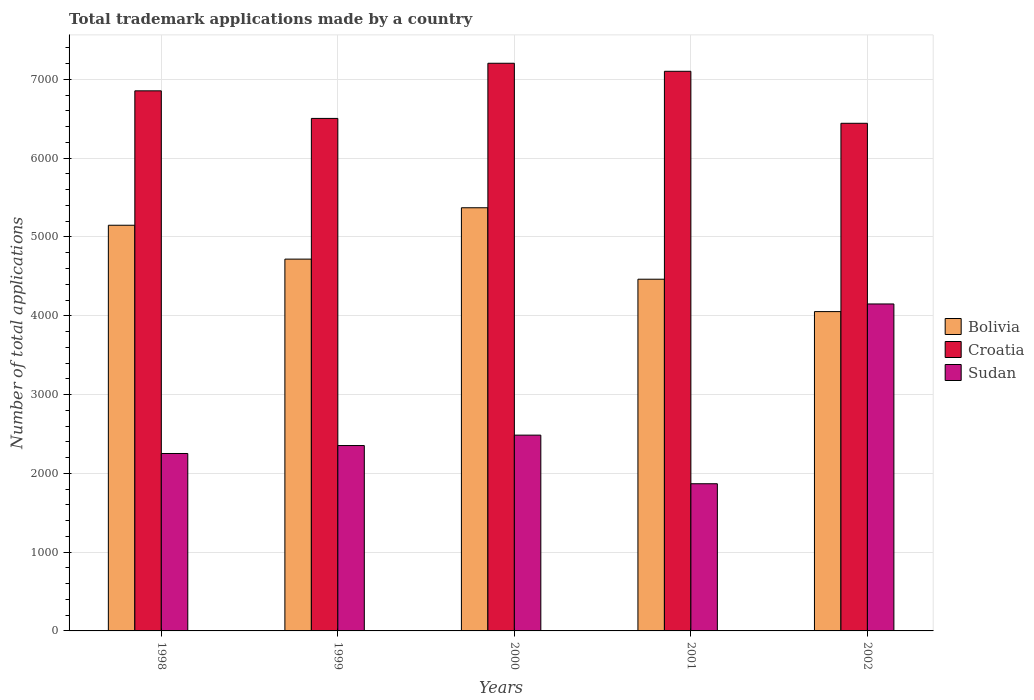How many different coloured bars are there?
Provide a short and direct response. 3. How many groups of bars are there?
Make the answer very short. 5. Are the number of bars on each tick of the X-axis equal?
Offer a terse response. Yes. How many bars are there on the 1st tick from the left?
Provide a short and direct response. 3. What is the number of applications made by in Sudan in 1999?
Provide a succinct answer. 2353. Across all years, what is the maximum number of applications made by in Croatia?
Your response must be concise. 7205. Across all years, what is the minimum number of applications made by in Bolivia?
Offer a terse response. 4053. In which year was the number of applications made by in Sudan maximum?
Make the answer very short. 2002. What is the total number of applications made by in Sudan in the graph?
Provide a short and direct response. 1.31e+04. What is the difference between the number of applications made by in Bolivia in 2001 and that in 2002?
Your answer should be compact. 411. What is the difference between the number of applications made by in Bolivia in 2002 and the number of applications made by in Croatia in 1999?
Make the answer very short. -2452. What is the average number of applications made by in Bolivia per year?
Keep it short and to the point. 4751.2. In the year 1998, what is the difference between the number of applications made by in Bolivia and number of applications made by in Croatia?
Your answer should be compact. -1706. What is the ratio of the number of applications made by in Sudan in 1998 to that in 1999?
Ensure brevity in your answer.  0.96. Is the number of applications made by in Croatia in 1998 less than that in 2002?
Your answer should be very brief. No. What is the difference between the highest and the second highest number of applications made by in Croatia?
Offer a very short reply. 102. What is the difference between the highest and the lowest number of applications made by in Bolivia?
Provide a succinct answer. 1318. What does the 3rd bar from the left in 2001 represents?
Offer a very short reply. Sudan. What does the 1st bar from the right in 2001 represents?
Your response must be concise. Sudan. Is it the case that in every year, the sum of the number of applications made by in Croatia and number of applications made by in Bolivia is greater than the number of applications made by in Sudan?
Provide a short and direct response. Yes. Does the graph contain any zero values?
Provide a succinct answer. No. Where does the legend appear in the graph?
Give a very brief answer. Center right. How many legend labels are there?
Your answer should be very brief. 3. What is the title of the graph?
Offer a very short reply. Total trademark applications made by a country. What is the label or title of the X-axis?
Make the answer very short. Years. What is the label or title of the Y-axis?
Ensure brevity in your answer.  Number of total applications. What is the Number of total applications in Bolivia in 1998?
Your response must be concise. 5149. What is the Number of total applications in Croatia in 1998?
Your response must be concise. 6855. What is the Number of total applications in Sudan in 1998?
Provide a short and direct response. 2252. What is the Number of total applications of Bolivia in 1999?
Provide a short and direct response. 4719. What is the Number of total applications of Croatia in 1999?
Offer a very short reply. 6505. What is the Number of total applications in Sudan in 1999?
Your answer should be compact. 2353. What is the Number of total applications of Bolivia in 2000?
Provide a succinct answer. 5371. What is the Number of total applications in Croatia in 2000?
Provide a succinct answer. 7205. What is the Number of total applications of Sudan in 2000?
Your answer should be very brief. 2485. What is the Number of total applications of Bolivia in 2001?
Offer a terse response. 4464. What is the Number of total applications in Croatia in 2001?
Give a very brief answer. 7103. What is the Number of total applications in Sudan in 2001?
Your answer should be very brief. 1868. What is the Number of total applications of Bolivia in 2002?
Your response must be concise. 4053. What is the Number of total applications in Croatia in 2002?
Keep it short and to the point. 6443. What is the Number of total applications in Sudan in 2002?
Ensure brevity in your answer.  4150. Across all years, what is the maximum Number of total applications of Bolivia?
Provide a short and direct response. 5371. Across all years, what is the maximum Number of total applications of Croatia?
Offer a very short reply. 7205. Across all years, what is the maximum Number of total applications in Sudan?
Your answer should be compact. 4150. Across all years, what is the minimum Number of total applications of Bolivia?
Ensure brevity in your answer.  4053. Across all years, what is the minimum Number of total applications in Croatia?
Provide a succinct answer. 6443. Across all years, what is the minimum Number of total applications in Sudan?
Give a very brief answer. 1868. What is the total Number of total applications in Bolivia in the graph?
Your response must be concise. 2.38e+04. What is the total Number of total applications of Croatia in the graph?
Your answer should be compact. 3.41e+04. What is the total Number of total applications of Sudan in the graph?
Give a very brief answer. 1.31e+04. What is the difference between the Number of total applications of Bolivia in 1998 and that in 1999?
Offer a very short reply. 430. What is the difference between the Number of total applications of Croatia in 1998 and that in 1999?
Ensure brevity in your answer.  350. What is the difference between the Number of total applications of Sudan in 1998 and that in 1999?
Offer a very short reply. -101. What is the difference between the Number of total applications in Bolivia in 1998 and that in 2000?
Keep it short and to the point. -222. What is the difference between the Number of total applications of Croatia in 1998 and that in 2000?
Make the answer very short. -350. What is the difference between the Number of total applications of Sudan in 1998 and that in 2000?
Give a very brief answer. -233. What is the difference between the Number of total applications in Bolivia in 1998 and that in 2001?
Keep it short and to the point. 685. What is the difference between the Number of total applications of Croatia in 1998 and that in 2001?
Make the answer very short. -248. What is the difference between the Number of total applications in Sudan in 1998 and that in 2001?
Give a very brief answer. 384. What is the difference between the Number of total applications of Bolivia in 1998 and that in 2002?
Keep it short and to the point. 1096. What is the difference between the Number of total applications of Croatia in 1998 and that in 2002?
Provide a short and direct response. 412. What is the difference between the Number of total applications of Sudan in 1998 and that in 2002?
Provide a short and direct response. -1898. What is the difference between the Number of total applications of Bolivia in 1999 and that in 2000?
Offer a very short reply. -652. What is the difference between the Number of total applications of Croatia in 1999 and that in 2000?
Your answer should be compact. -700. What is the difference between the Number of total applications of Sudan in 1999 and that in 2000?
Make the answer very short. -132. What is the difference between the Number of total applications of Bolivia in 1999 and that in 2001?
Provide a succinct answer. 255. What is the difference between the Number of total applications of Croatia in 1999 and that in 2001?
Keep it short and to the point. -598. What is the difference between the Number of total applications of Sudan in 1999 and that in 2001?
Offer a very short reply. 485. What is the difference between the Number of total applications in Bolivia in 1999 and that in 2002?
Your response must be concise. 666. What is the difference between the Number of total applications in Croatia in 1999 and that in 2002?
Your answer should be compact. 62. What is the difference between the Number of total applications of Sudan in 1999 and that in 2002?
Ensure brevity in your answer.  -1797. What is the difference between the Number of total applications of Bolivia in 2000 and that in 2001?
Offer a terse response. 907. What is the difference between the Number of total applications in Croatia in 2000 and that in 2001?
Your answer should be very brief. 102. What is the difference between the Number of total applications in Sudan in 2000 and that in 2001?
Offer a very short reply. 617. What is the difference between the Number of total applications of Bolivia in 2000 and that in 2002?
Ensure brevity in your answer.  1318. What is the difference between the Number of total applications in Croatia in 2000 and that in 2002?
Make the answer very short. 762. What is the difference between the Number of total applications in Sudan in 2000 and that in 2002?
Make the answer very short. -1665. What is the difference between the Number of total applications in Bolivia in 2001 and that in 2002?
Your answer should be very brief. 411. What is the difference between the Number of total applications of Croatia in 2001 and that in 2002?
Give a very brief answer. 660. What is the difference between the Number of total applications of Sudan in 2001 and that in 2002?
Your response must be concise. -2282. What is the difference between the Number of total applications in Bolivia in 1998 and the Number of total applications in Croatia in 1999?
Provide a short and direct response. -1356. What is the difference between the Number of total applications in Bolivia in 1998 and the Number of total applications in Sudan in 1999?
Give a very brief answer. 2796. What is the difference between the Number of total applications of Croatia in 1998 and the Number of total applications of Sudan in 1999?
Your answer should be compact. 4502. What is the difference between the Number of total applications in Bolivia in 1998 and the Number of total applications in Croatia in 2000?
Your answer should be very brief. -2056. What is the difference between the Number of total applications in Bolivia in 1998 and the Number of total applications in Sudan in 2000?
Provide a short and direct response. 2664. What is the difference between the Number of total applications of Croatia in 1998 and the Number of total applications of Sudan in 2000?
Provide a short and direct response. 4370. What is the difference between the Number of total applications of Bolivia in 1998 and the Number of total applications of Croatia in 2001?
Provide a short and direct response. -1954. What is the difference between the Number of total applications of Bolivia in 1998 and the Number of total applications of Sudan in 2001?
Provide a short and direct response. 3281. What is the difference between the Number of total applications of Croatia in 1998 and the Number of total applications of Sudan in 2001?
Offer a very short reply. 4987. What is the difference between the Number of total applications in Bolivia in 1998 and the Number of total applications in Croatia in 2002?
Provide a short and direct response. -1294. What is the difference between the Number of total applications in Bolivia in 1998 and the Number of total applications in Sudan in 2002?
Make the answer very short. 999. What is the difference between the Number of total applications in Croatia in 1998 and the Number of total applications in Sudan in 2002?
Provide a short and direct response. 2705. What is the difference between the Number of total applications of Bolivia in 1999 and the Number of total applications of Croatia in 2000?
Provide a short and direct response. -2486. What is the difference between the Number of total applications in Bolivia in 1999 and the Number of total applications in Sudan in 2000?
Your answer should be very brief. 2234. What is the difference between the Number of total applications in Croatia in 1999 and the Number of total applications in Sudan in 2000?
Keep it short and to the point. 4020. What is the difference between the Number of total applications of Bolivia in 1999 and the Number of total applications of Croatia in 2001?
Provide a short and direct response. -2384. What is the difference between the Number of total applications of Bolivia in 1999 and the Number of total applications of Sudan in 2001?
Your answer should be compact. 2851. What is the difference between the Number of total applications of Croatia in 1999 and the Number of total applications of Sudan in 2001?
Make the answer very short. 4637. What is the difference between the Number of total applications in Bolivia in 1999 and the Number of total applications in Croatia in 2002?
Keep it short and to the point. -1724. What is the difference between the Number of total applications in Bolivia in 1999 and the Number of total applications in Sudan in 2002?
Ensure brevity in your answer.  569. What is the difference between the Number of total applications of Croatia in 1999 and the Number of total applications of Sudan in 2002?
Keep it short and to the point. 2355. What is the difference between the Number of total applications in Bolivia in 2000 and the Number of total applications in Croatia in 2001?
Give a very brief answer. -1732. What is the difference between the Number of total applications of Bolivia in 2000 and the Number of total applications of Sudan in 2001?
Your answer should be very brief. 3503. What is the difference between the Number of total applications in Croatia in 2000 and the Number of total applications in Sudan in 2001?
Keep it short and to the point. 5337. What is the difference between the Number of total applications in Bolivia in 2000 and the Number of total applications in Croatia in 2002?
Make the answer very short. -1072. What is the difference between the Number of total applications of Bolivia in 2000 and the Number of total applications of Sudan in 2002?
Provide a succinct answer. 1221. What is the difference between the Number of total applications in Croatia in 2000 and the Number of total applications in Sudan in 2002?
Your response must be concise. 3055. What is the difference between the Number of total applications of Bolivia in 2001 and the Number of total applications of Croatia in 2002?
Provide a succinct answer. -1979. What is the difference between the Number of total applications of Bolivia in 2001 and the Number of total applications of Sudan in 2002?
Offer a very short reply. 314. What is the difference between the Number of total applications in Croatia in 2001 and the Number of total applications in Sudan in 2002?
Make the answer very short. 2953. What is the average Number of total applications in Bolivia per year?
Provide a short and direct response. 4751.2. What is the average Number of total applications in Croatia per year?
Offer a very short reply. 6822.2. What is the average Number of total applications in Sudan per year?
Provide a succinct answer. 2621.6. In the year 1998, what is the difference between the Number of total applications of Bolivia and Number of total applications of Croatia?
Keep it short and to the point. -1706. In the year 1998, what is the difference between the Number of total applications in Bolivia and Number of total applications in Sudan?
Provide a succinct answer. 2897. In the year 1998, what is the difference between the Number of total applications of Croatia and Number of total applications of Sudan?
Provide a short and direct response. 4603. In the year 1999, what is the difference between the Number of total applications in Bolivia and Number of total applications in Croatia?
Ensure brevity in your answer.  -1786. In the year 1999, what is the difference between the Number of total applications in Bolivia and Number of total applications in Sudan?
Give a very brief answer. 2366. In the year 1999, what is the difference between the Number of total applications in Croatia and Number of total applications in Sudan?
Provide a succinct answer. 4152. In the year 2000, what is the difference between the Number of total applications in Bolivia and Number of total applications in Croatia?
Ensure brevity in your answer.  -1834. In the year 2000, what is the difference between the Number of total applications of Bolivia and Number of total applications of Sudan?
Make the answer very short. 2886. In the year 2000, what is the difference between the Number of total applications of Croatia and Number of total applications of Sudan?
Your answer should be very brief. 4720. In the year 2001, what is the difference between the Number of total applications of Bolivia and Number of total applications of Croatia?
Provide a short and direct response. -2639. In the year 2001, what is the difference between the Number of total applications in Bolivia and Number of total applications in Sudan?
Keep it short and to the point. 2596. In the year 2001, what is the difference between the Number of total applications in Croatia and Number of total applications in Sudan?
Provide a short and direct response. 5235. In the year 2002, what is the difference between the Number of total applications of Bolivia and Number of total applications of Croatia?
Make the answer very short. -2390. In the year 2002, what is the difference between the Number of total applications in Bolivia and Number of total applications in Sudan?
Keep it short and to the point. -97. In the year 2002, what is the difference between the Number of total applications of Croatia and Number of total applications of Sudan?
Give a very brief answer. 2293. What is the ratio of the Number of total applications in Bolivia in 1998 to that in 1999?
Your answer should be compact. 1.09. What is the ratio of the Number of total applications in Croatia in 1998 to that in 1999?
Offer a very short reply. 1.05. What is the ratio of the Number of total applications in Sudan in 1998 to that in 1999?
Offer a very short reply. 0.96. What is the ratio of the Number of total applications of Bolivia in 1998 to that in 2000?
Provide a succinct answer. 0.96. What is the ratio of the Number of total applications of Croatia in 1998 to that in 2000?
Keep it short and to the point. 0.95. What is the ratio of the Number of total applications of Sudan in 1998 to that in 2000?
Provide a succinct answer. 0.91. What is the ratio of the Number of total applications in Bolivia in 1998 to that in 2001?
Your response must be concise. 1.15. What is the ratio of the Number of total applications in Croatia in 1998 to that in 2001?
Keep it short and to the point. 0.97. What is the ratio of the Number of total applications in Sudan in 1998 to that in 2001?
Your answer should be very brief. 1.21. What is the ratio of the Number of total applications of Bolivia in 1998 to that in 2002?
Make the answer very short. 1.27. What is the ratio of the Number of total applications in Croatia in 1998 to that in 2002?
Give a very brief answer. 1.06. What is the ratio of the Number of total applications in Sudan in 1998 to that in 2002?
Your answer should be compact. 0.54. What is the ratio of the Number of total applications in Bolivia in 1999 to that in 2000?
Keep it short and to the point. 0.88. What is the ratio of the Number of total applications in Croatia in 1999 to that in 2000?
Your answer should be compact. 0.9. What is the ratio of the Number of total applications in Sudan in 1999 to that in 2000?
Ensure brevity in your answer.  0.95. What is the ratio of the Number of total applications of Bolivia in 1999 to that in 2001?
Give a very brief answer. 1.06. What is the ratio of the Number of total applications in Croatia in 1999 to that in 2001?
Provide a short and direct response. 0.92. What is the ratio of the Number of total applications in Sudan in 1999 to that in 2001?
Provide a short and direct response. 1.26. What is the ratio of the Number of total applications in Bolivia in 1999 to that in 2002?
Your response must be concise. 1.16. What is the ratio of the Number of total applications in Croatia in 1999 to that in 2002?
Ensure brevity in your answer.  1.01. What is the ratio of the Number of total applications of Sudan in 1999 to that in 2002?
Offer a terse response. 0.57. What is the ratio of the Number of total applications of Bolivia in 2000 to that in 2001?
Provide a succinct answer. 1.2. What is the ratio of the Number of total applications of Croatia in 2000 to that in 2001?
Your answer should be compact. 1.01. What is the ratio of the Number of total applications of Sudan in 2000 to that in 2001?
Offer a terse response. 1.33. What is the ratio of the Number of total applications of Bolivia in 2000 to that in 2002?
Your answer should be compact. 1.33. What is the ratio of the Number of total applications in Croatia in 2000 to that in 2002?
Make the answer very short. 1.12. What is the ratio of the Number of total applications of Sudan in 2000 to that in 2002?
Your answer should be compact. 0.6. What is the ratio of the Number of total applications of Bolivia in 2001 to that in 2002?
Offer a terse response. 1.1. What is the ratio of the Number of total applications in Croatia in 2001 to that in 2002?
Provide a succinct answer. 1.1. What is the ratio of the Number of total applications in Sudan in 2001 to that in 2002?
Your answer should be compact. 0.45. What is the difference between the highest and the second highest Number of total applications in Bolivia?
Ensure brevity in your answer.  222. What is the difference between the highest and the second highest Number of total applications of Croatia?
Offer a terse response. 102. What is the difference between the highest and the second highest Number of total applications in Sudan?
Your answer should be very brief. 1665. What is the difference between the highest and the lowest Number of total applications in Bolivia?
Your response must be concise. 1318. What is the difference between the highest and the lowest Number of total applications in Croatia?
Ensure brevity in your answer.  762. What is the difference between the highest and the lowest Number of total applications in Sudan?
Ensure brevity in your answer.  2282. 